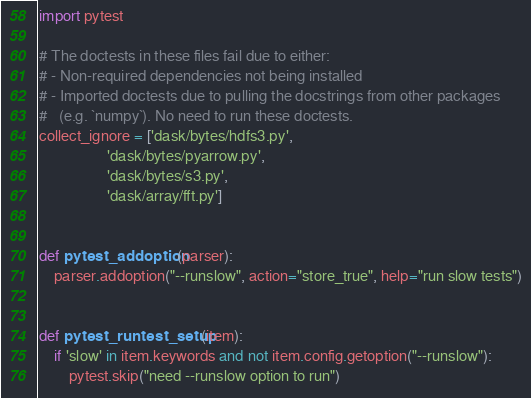Convert code to text. <code><loc_0><loc_0><loc_500><loc_500><_Python_>import pytest

# The doctests in these files fail due to either:
# - Non-required dependencies not being installed
# - Imported doctests due to pulling the docstrings from other packages
#   (e.g. `numpy`). No need to run these doctests.
collect_ignore = ['dask/bytes/hdfs3.py',
                  'dask/bytes/pyarrow.py',
                  'dask/bytes/s3.py',
                  'dask/array/fft.py']


def pytest_addoption(parser):
    parser.addoption("--runslow", action="store_true", help="run slow tests")


def pytest_runtest_setup(item):
    if 'slow' in item.keywords and not item.config.getoption("--runslow"):
        pytest.skip("need --runslow option to run")
</code> 